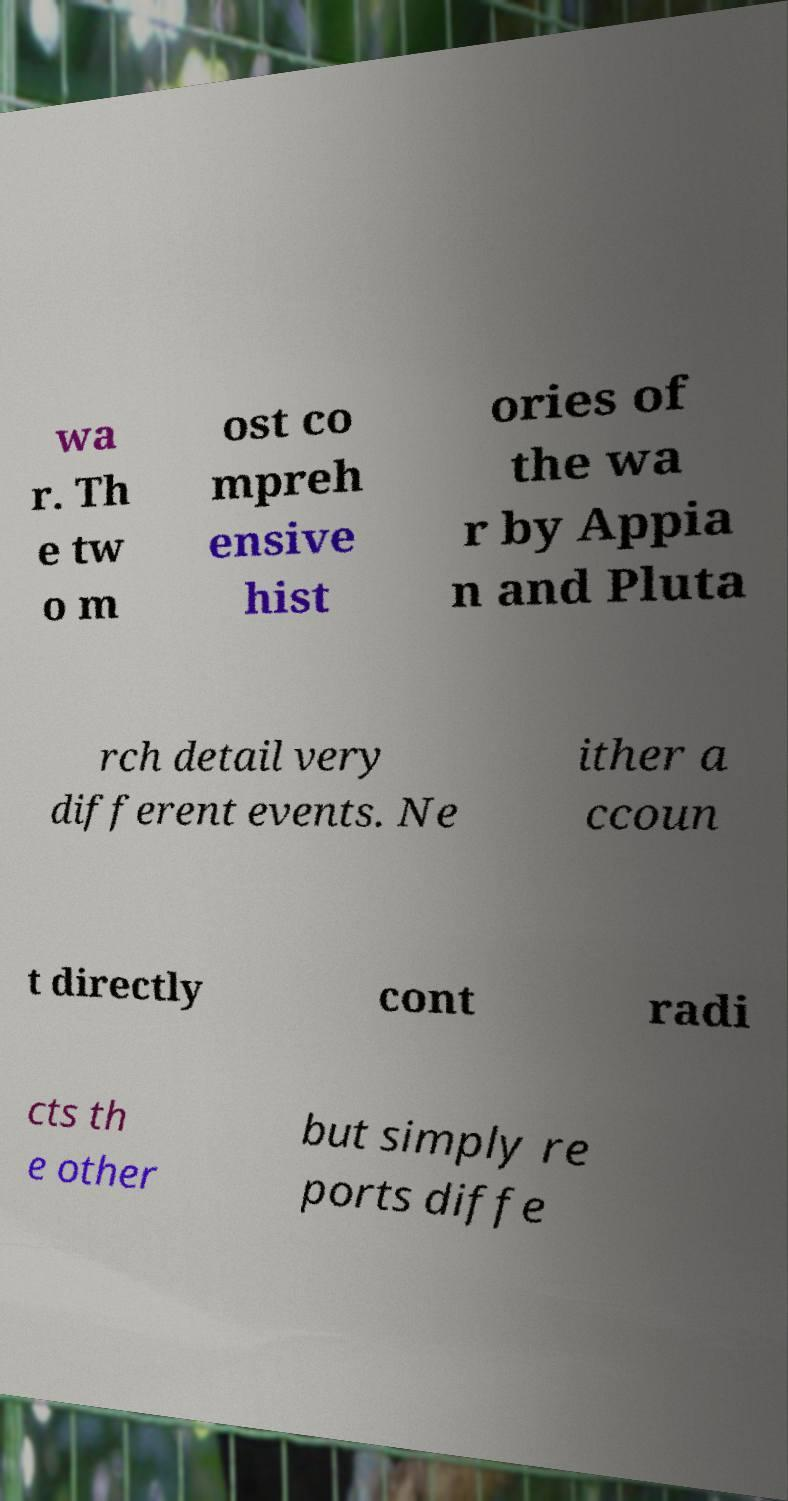There's text embedded in this image that I need extracted. Can you transcribe it verbatim? wa r. Th e tw o m ost co mpreh ensive hist ories of the wa r by Appia n and Pluta rch detail very different events. Ne ither a ccoun t directly cont radi cts th e other but simply re ports diffe 